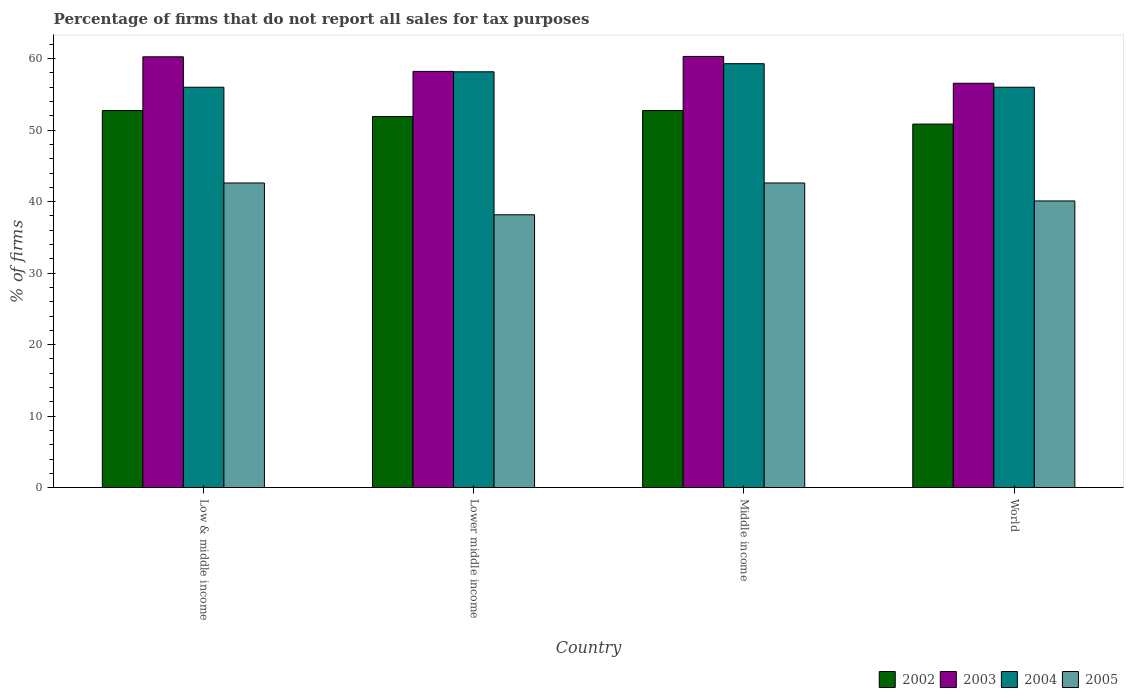How many different coloured bars are there?
Your response must be concise. 4. How many groups of bars are there?
Offer a terse response. 4. Are the number of bars per tick equal to the number of legend labels?
Your response must be concise. Yes. In how many cases, is the number of bars for a given country not equal to the number of legend labels?
Offer a very short reply. 0. What is the percentage of firms that do not report all sales for tax purposes in 2002 in Middle income?
Your answer should be compact. 52.75. Across all countries, what is the maximum percentage of firms that do not report all sales for tax purposes in 2002?
Give a very brief answer. 52.75. Across all countries, what is the minimum percentage of firms that do not report all sales for tax purposes in 2002?
Offer a very short reply. 50.85. What is the total percentage of firms that do not report all sales for tax purposes in 2002 in the graph?
Keep it short and to the point. 208.25. What is the difference between the percentage of firms that do not report all sales for tax purposes in 2003 in Low & middle income and that in Middle income?
Give a very brief answer. -0.05. What is the difference between the percentage of firms that do not report all sales for tax purposes in 2004 in Low & middle income and the percentage of firms that do not report all sales for tax purposes in 2003 in Middle income?
Offer a terse response. -4.31. What is the average percentage of firms that do not report all sales for tax purposes in 2002 per country?
Offer a terse response. 52.06. What is the difference between the percentage of firms that do not report all sales for tax purposes of/in 2005 and percentage of firms that do not report all sales for tax purposes of/in 2002 in Middle income?
Provide a succinct answer. -10.13. What is the ratio of the percentage of firms that do not report all sales for tax purposes in 2004 in Low & middle income to that in Lower middle income?
Provide a succinct answer. 0.96. Is the percentage of firms that do not report all sales for tax purposes in 2002 in Middle income less than that in World?
Offer a very short reply. No. Is the difference between the percentage of firms that do not report all sales for tax purposes in 2005 in Low & middle income and Lower middle income greater than the difference between the percentage of firms that do not report all sales for tax purposes in 2002 in Low & middle income and Lower middle income?
Provide a succinct answer. Yes. What is the difference between the highest and the second highest percentage of firms that do not report all sales for tax purposes in 2002?
Give a very brief answer. -0.84. What is the difference between the highest and the lowest percentage of firms that do not report all sales for tax purposes in 2002?
Make the answer very short. 1.89. Is it the case that in every country, the sum of the percentage of firms that do not report all sales for tax purposes in 2004 and percentage of firms that do not report all sales for tax purposes in 2003 is greater than the sum of percentage of firms that do not report all sales for tax purposes in 2002 and percentage of firms that do not report all sales for tax purposes in 2005?
Provide a succinct answer. Yes. What does the 2nd bar from the right in Middle income represents?
Ensure brevity in your answer.  2004. Is it the case that in every country, the sum of the percentage of firms that do not report all sales for tax purposes in 2004 and percentage of firms that do not report all sales for tax purposes in 2005 is greater than the percentage of firms that do not report all sales for tax purposes in 2003?
Provide a short and direct response. Yes. What is the difference between two consecutive major ticks on the Y-axis?
Provide a succinct answer. 10. Are the values on the major ticks of Y-axis written in scientific E-notation?
Your answer should be very brief. No. Does the graph contain any zero values?
Provide a short and direct response. No. How many legend labels are there?
Your answer should be very brief. 4. What is the title of the graph?
Your answer should be compact. Percentage of firms that do not report all sales for tax purposes. What is the label or title of the Y-axis?
Give a very brief answer. % of firms. What is the % of firms of 2002 in Low & middle income?
Your answer should be compact. 52.75. What is the % of firms in 2003 in Low & middle income?
Your answer should be very brief. 60.26. What is the % of firms of 2004 in Low & middle income?
Keep it short and to the point. 56.01. What is the % of firms of 2005 in Low & middle income?
Offer a very short reply. 42.61. What is the % of firms in 2002 in Lower middle income?
Your response must be concise. 51.91. What is the % of firms in 2003 in Lower middle income?
Ensure brevity in your answer.  58.22. What is the % of firms in 2004 in Lower middle income?
Your answer should be very brief. 58.16. What is the % of firms in 2005 in Lower middle income?
Your answer should be compact. 38.16. What is the % of firms in 2002 in Middle income?
Offer a very short reply. 52.75. What is the % of firms in 2003 in Middle income?
Offer a very short reply. 60.31. What is the % of firms in 2004 in Middle income?
Ensure brevity in your answer.  59.3. What is the % of firms in 2005 in Middle income?
Give a very brief answer. 42.61. What is the % of firms in 2002 in World?
Give a very brief answer. 50.85. What is the % of firms of 2003 in World?
Provide a succinct answer. 56.56. What is the % of firms of 2004 in World?
Your answer should be very brief. 56.01. What is the % of firms of 2005 in World?
Provide a short and direct response. 40.1. Across all countries, what is the maximum % of firms of 2002?
Keep it short and to the point. 52.75. Across all countries, what is the maximum % of firms in 2003?
Give a very brief answer. 60.31. Across all countries, what is the maximum % of firms of 2004?
Provide a short and direct response. 59.3. Across all countries, what is the maximum % of firms in 2005?
Give a very brief answer. 42.61. Across all countries, what is the minimum % of firms of 2002?
Offer a very short reply. 50.85. Across all countries, what is the minimum % of firms in 2003?
Your response must be concise. 56.56. Across all countries, what is the minimum % of firms of 2004?
Provide a succinct answer. 56.01. Across all countries, what is the minimum % of firms of 2005?
Ensure brevity in your answer.  38.16. What is the total % of firms of 2002 in the graph?
Provide a short and direct response. 208.25. What is the total % of firms in 2003 in the graph?
Offer a terse response. 235.35. What is the total % of firms in 2004 in the graph?
Provide a short and direct response. 229.47. What is the total % of firms of 2005 in the graph?
Make the answer very short. 163.48. What is the difference between the % of firms of 2002 in Low & middle income and that in Lower middle income?
Your response must be concise. 0.84. What is the difference between the % of firms of 2003 in Low & middle income and that in Lower middle income?
Offer a terse response. 2.04. What is the difference between the % of firms in 2004 in Low & middle income and that in Lower middle income?
Your response must be concise. -2.16. What is the difference between the % of firms in 2005 in Low & middle income and that in Lower middle income?
Make the answer very short. 4.45. What is the difference between the % of firms in 2003 in Low & middle income and that in Middle income?
Provide a succinct answer. -0.05. What is the difference between the % of firms in 2004 in Low & middle income and that in Middle income?
Ensure brevity in your answer.  -3.29. What is the difference between the % of firms of 2002 in Low & middle income and that in World?
Keep it short and to the point. 1.89. What is the difference between the % of firms in 2005 in Low & middle income and that in World?
Keep it short and to the point. 2.51. What is the difference between the % of firms of 2002 in Lower middle income and that in Middle income?
Give a very brief answer. -0.84. What is the difference between the % of firms in 2003 in Lower middle income and that in Middle income?
Offer a very short reply. -2.09. What is the difference between the % of firms in 2004 in Lower middle income and that in Middle income?
Provide a succinct answer. -1.13. What is the difference between the % of firms in 2005 in Lower middle income and that in Middle income?
Your answer should be compact. -4.45. What is the difference between the % of firms of 2002 in Lower middle income and that in World?
Give a very brief answer. 1.06. What is the difference between the % of firms of 2003 in Lower middle income and that in World?
Provide a succinct answer. 1.66. What is the difference between the % of firms of 2004 in Lower middle income and that in World?
Offer a very short reply. 2.16. What is the difference between the % of firms of 2005 in Lower middle income and that in World?
Give a very brief answer. -1.94. What is the difference between the % of firms of 2002 in Middle income and that in World?
Ensure brevity in your answer.  1.89. What is the difference between the % of firms of 2003 in Middle income and that in World?
Your response must be concise. 3.75. What is the difference between the % of firms of 2004 in Middle income and that in World?
Ensure brevity in your answer.  3.29. What is the difference between the % of firms in 2005 in Middle income and that in World?
Your response must be concise. 2.51. What is the difference between the % of firms in 2002 in Low & middle income and the % of firms in 2003 in Lower middle income?
Your answer should be very brief. -5.47. What is the difference between the % of firms of 2002 in Low & middle income and the % of firms of 2004 in Lower middle income?
Your response must be concise. -5.42. What is the difference between the % of firms in 2002 in Low & middle income and the % of firms in 2005 in Lower middle income?
Your answer should be compact. 14.58. What is the difference between the % of firms in 2003 in Low & middle income and the % of firms in 2004 in Lower middle income?
Provide a succinct answer. 2.1. What is the difference between the % of firms in 2003 in Low & middle income and the % of firms in 2005 in Lower middle income?
Keep it short and to the point. 22.1. What is the difference between the % of firms in 2004 in Low & middle income and the % of firms in 2005 in Lower middle income?
Provide a succinct answer. 17.84. What is the difference between the % of firms of 2002 in Low & middle income and the % of firms of 2003 in Middle income?
Your answer should be very brief. -7.57. What is the difference between the % of firms in 2002 in Low & middle income and the % of firms in 2004 in Middle income?
Your answer should be compact. -6.55. What is the difference between the % of firms in 2002 in Low & middle income and the % of firms in 2005 in Middle income?
Ensure brevity in your answer.  10.13. What is the difference between the % of firms of 2003 in Low & middle income and the % of firms of 2004 in Middle income?
Your answer should be very brief. 0.96. What is the difference between the % of firms of 2003 in Low & middle income and the % of firms of 2005 in Middle income?
Keep it short and to the point. 17.65. What is the difference between the % of firms in 2004 in Low & middle income and the % of firms in 2005 in Middle income?
Offer a terse response. 13.39. What is the difference between the % of firms of 2002 in Low & middle income and the % of firms of 2003 in World?
Provide a succinct answer. -3.81. What is the difference between the % of firms of 2002 in Low & middle income and the % of firms of 2004 in World?
Offer a very short reply. -3.26. What is the difference between the % of firms of 2002 in Low & middle income and the % of firms of 2005 in World?
Offer a very short reply. 12.65. What is the difference between the % of firms of 2003 in Low & middle income and the % of firms of 2004 in World?
Your answer should be compact. 4.25. What is the difference between the % of firms in 2003 in Low & middle income and the % of firms in 2005 in World?
Keep it short and to the point. 20.16. What is the difference between the % of firms of 2004 in Low & middle income and the % of firms of 2005 in World?
Make the answer very short. 15.91. What is the difference between the % of firms in 2002 in Lower middle income and the % of firms in 2003 in Middle income?
Provide a short and direct response. -8.4. What is the difference between the % of firms in 2002 in Lower middle income and the % of firms in 2004 in Middle income?
Offer a very short reply. -7.39. What is the difference between the % of firms in 2002 in Lower middle income and the % of firms in 2005 in Middle income?
Your response must be concise. 9.3. What is the difference between the % of firms in 2003 in Lower middle income and the % of firms in 2004 in Middle income?
Provide a short and direct response. -1.08. What is the difference between the % of firms in 2003 in Lower middle income and the % of firms in 2005 in Middle income?
Keep it short and to the point. 15.61. What is the difference between the % of firms of 2004 in Lower middle income and the % of firms of 2005 in Middle income?
Keep it short and to the point. 15.55. What is the difference between the % of firms in 2002 in Lower middle income and the % of firms in 2003 in World?
Offer a very short reply. -4.65. What is the difference between the % of firms of 2002 in Lower middle income and the % of firms of 2004 in World?
Keep it short and to the point. -4.1. What is the difference between the % of firms in 2002 in Lower middle income and the % of firms in 2005 in World?
Provide a succinct answer. 11.81. What is the difference between the % of firms of 2003 in Lower middle income and the % of firms of 2004 in World?
Your answer should be very brief. 2.21. What is the difference between the % of firms in 2003 in Lower middle income and the % of firms in 2005 in World?
Give a very brief answer. 18.12. What is the difference between the % of firms of 2004 in Lower middle income and the % of firms of 2005 in World?
Offer a terse response. 18.07. What is the difference between the % of firms in 2002 in Middle income and the % of firms in 2003 in World?
Your answer should be very brief. -3.81. What is the difference between the % of firms of 2002 in Middle income and the % of firms of 2004 in World?
Provide a short and direct response. -3.26. What is the difference between the % of firms of 2002 in Middle income and the % of firms of 2005 in World?
Provide a short and direct response. 12.65. What is the difference between the % of firms of 2003 in Middle income and the % of firms of 2004 in World?
Offer a very short reply. 4.31. What is the difference between the % of firms of 2003 in Middle income and the % of firms of 2005 in World?
Offer a very short reply. 20.21. What is the difference between the % of firms of 2004 in Middle income and the % of firms of 2005 in World?
Give a very brief answer. 19.2. What is the average % of firms of 2002 per country?
Keep it short and to the point. 52.06. What is the average % of firms in 2003 per country?
Offer a terse response. 58.84. What is the average % of firms in 2004 per country?
Provide a succinct answer. 57.37. What is the average % of firms of 2005 per country?
Provide a short and direct response. 40.87. What is the difference between the % of firms of 2002 and % of firms of 2003 in Low & middle income?
Give a very brief answer. -7.51. What is the difference between the % of firms in 2002 and % of firms in 2004 in Low & middle income?
Offer a terse response. -3.26. What is the difference between the % of firms in 2002 and % of firms in 2005 in Low & middle income?
Your response must be concise. 10.13. What is the difference between the % of firms of 2003 and % of firms of 2004 in Low & middle income?
Your answer should be very brief. 4.25. What is the difference between the % of firms of 2003 and % of firms of 2005 in Low & middle income?
Offer a very short reply. 17.65. What is the difference between the % of firms in 2004 and % of firms in 2005 in Low & middle income?
Offer a very short reply. 13.39. What is the difference between the % of firms of 2002 and % of firms of 2003 in Lower middle income?
Provide a succinct answer. -6.31. What is the difference between the % of firms in 2002 and % of firms in 2004 in Lower middle income?
Offer a terse response. -6.26. What is the difference between the % of firms of 2002 and % of firms of 2005 in Lower middle income?
Give a very brief answer. 13.75. What is the difference between the % of firms of 2003 and % of firms of 2004 in Lower middle income?
Offer a terse response. 0.05. What is the difference between the % of firms of 2003 and % of firms of 2005 in Lower middle income?
Keep it short and to the point. 20.06. What is the difference between the % of firms in 2004 and % of firms in 2005 in Lower middle income?
Ensure brevity in your answer.  20. What is the difference between the % of firms of 2002 and % of firms of 2003 in Middle income?
Your response must be concise. -7.57. What is the difference between the % of firms of 2002 and % of firms of 2004 in Middle income?
Provide a short and direct response. -6.55. What is the difference between the % of firms of 2002 and % of firms of 2005 in Middle income?
Your answer should be compact. 10.13. What is the difference between the % of firms in 2003 and % of firms in 2004 in Middle income?
Provide a succinct answer. 1.02. What is the difference between the % of firms of 2003 and % of firms of 2005 in Middle income?
Provide a short and direct response. 17.7. What is the difference between the % of firms of 2004 and % of firms of 2005 in Middle income?
Your response must be concise. 16.69. What is the difference between the % of firms in 2002 and % of firms in 2003 in World?
Make the answer very short. -5.71. What is the difference between the % of firms in 2002 and % of firms in 2004 in World?
Offer a very short reply. -5.15. What is the difference between the % of firms in 2002 and % of firms in 2005 in World?
Offer a terse response. 10.75. What is the difference between the % of firms of 2003 and % of firms of 2004 in World?
Provide a short and direct response. 0.56. What is the difference between the % of firms of 2003 and % of firms of 2005 in World?
Your answer should be compact. 16.46. What is the difference between the % of firms of 2004 and % of firms of 2005 in World?
Your response must be concise. 15.91. What is the ratio of the % of firms in 2002 in Low & middle income to that in Lower middle income?
Ensure brevity in your answer.  1.02. What is the ratio of the % of firms in 2003 in Low & middle income to that in Lower middle income?
Offer a very short reply. 1.04. What is the ratio of the % of firms in 2004 in Low & middle income to that in Lower middle income?
Keep it short and to the point. 0.96. What is the ratio of the % of firms in 2005 in Low & middle income to that in Lower middle income?
Offer a terse response. 1.12. What is the ratio of the % of firms in 2004 in Low & middle income to that in Middle income?
Your answer should be compact. 0.94. What is the ratio of the % of firms of 2002 in Low & middle income to that in World?
Make the answer very short. 1.04. What is the ratio of the % of firms of 2003 in Low & middle income to that in World?
Keep it short and to the point. 1.07. What is the ratio of the % of firms of 2004 in Low & middle income to that in World?
Your answer should be very brief. 1. What is the ratio of the % of firms in 2005 in Low & middle income to that in World?
Give a very brief answer. 1.06. What is the ratio of the % of firms of 2002 in Lower middle income to that in Middle income?
Offer a very short reply. 0.98. What is the ratio of the % of firms in 2003 in Lower middle income to that in Middle income?
Ensure brevity in your answer.  0.97. What is the ratio of the % of firms in 2004 in Lower middle income to that in Middle income?
Offer a terse response. 0.98. What is the ratio of the % of firms of 2005 in Lower middle income to that in Middle income?
Give a very brief answer. 0.9. What is the ratio of the % of firms in 2002 in Lower middle income to that in World?
Your response must be concise. 1.02. What is the ratio of the % of firms of 2003 in Lower middle income to that in World?
Offer a very short reply. 1.03. What is the ratio of the % of firms of 2004 in Lower middle income to that in World?
Ensure brevity in your answer.  1.04. What is the ratio of the % of firms of 2005 in Lower middle income to that in World?
Offer a very short reply. 0.95. What is the ratio of the % of firms of 2002 in Middle income to that in World?
Give a very brief answer. 1.04. What is the ratio of the % of firms in 2003 in Middle income to that in World?
Offer a very short reply. 1.07. What is the ratio of the % of firms of 2004 in Middle income to that in World?
Your answer should be compact. 1.06. What is the ratio of the % of firms in 2005 in Middle income to that in World?
Give a very brief answer. 1.06. What is the difference between the highest and the second highest % of firms in 2003?
Provide a succinct answer. 0.05. What is the difference between the highest and the second highest % of firms of 2004?
Provide a succinct answer. 1.13. What is the difference between the highest and the lowest % of firms in 2002?
Make the answer very short. 1.89. What is the difference between the highest and the lowest % of firms in 2003?
Make the answer very short. 3.75. What is the difference between the highest and the lowest % of firms in 2004?
Give a very brief answer. 3.29. What is the difference between the highest and the lowest % of firms in 2005?
Your response must be concise. 4.45. 